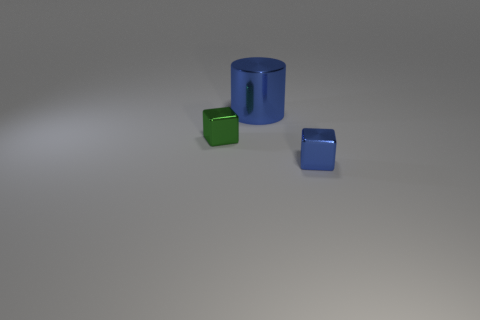Add 3 purple blocks. How many objects exist? 6 Subtract all blocks. How many objects are left? 1 Subtract 2 cubes. How many cubes are left? 0 Subtract all cyan cylinders. Subtract all red blocks. How many cylinders are left? 1 Add 3 green shiny things. How many green shiny things are left? 4 Add 2 green metallic blocks. How many green metallic blocks exist? 3 Subtract 0 yellow blocks. How many objects are left? 3 Subtract all tiny green matte objects. Subtract all large cylinders. How many objects are left? 2 